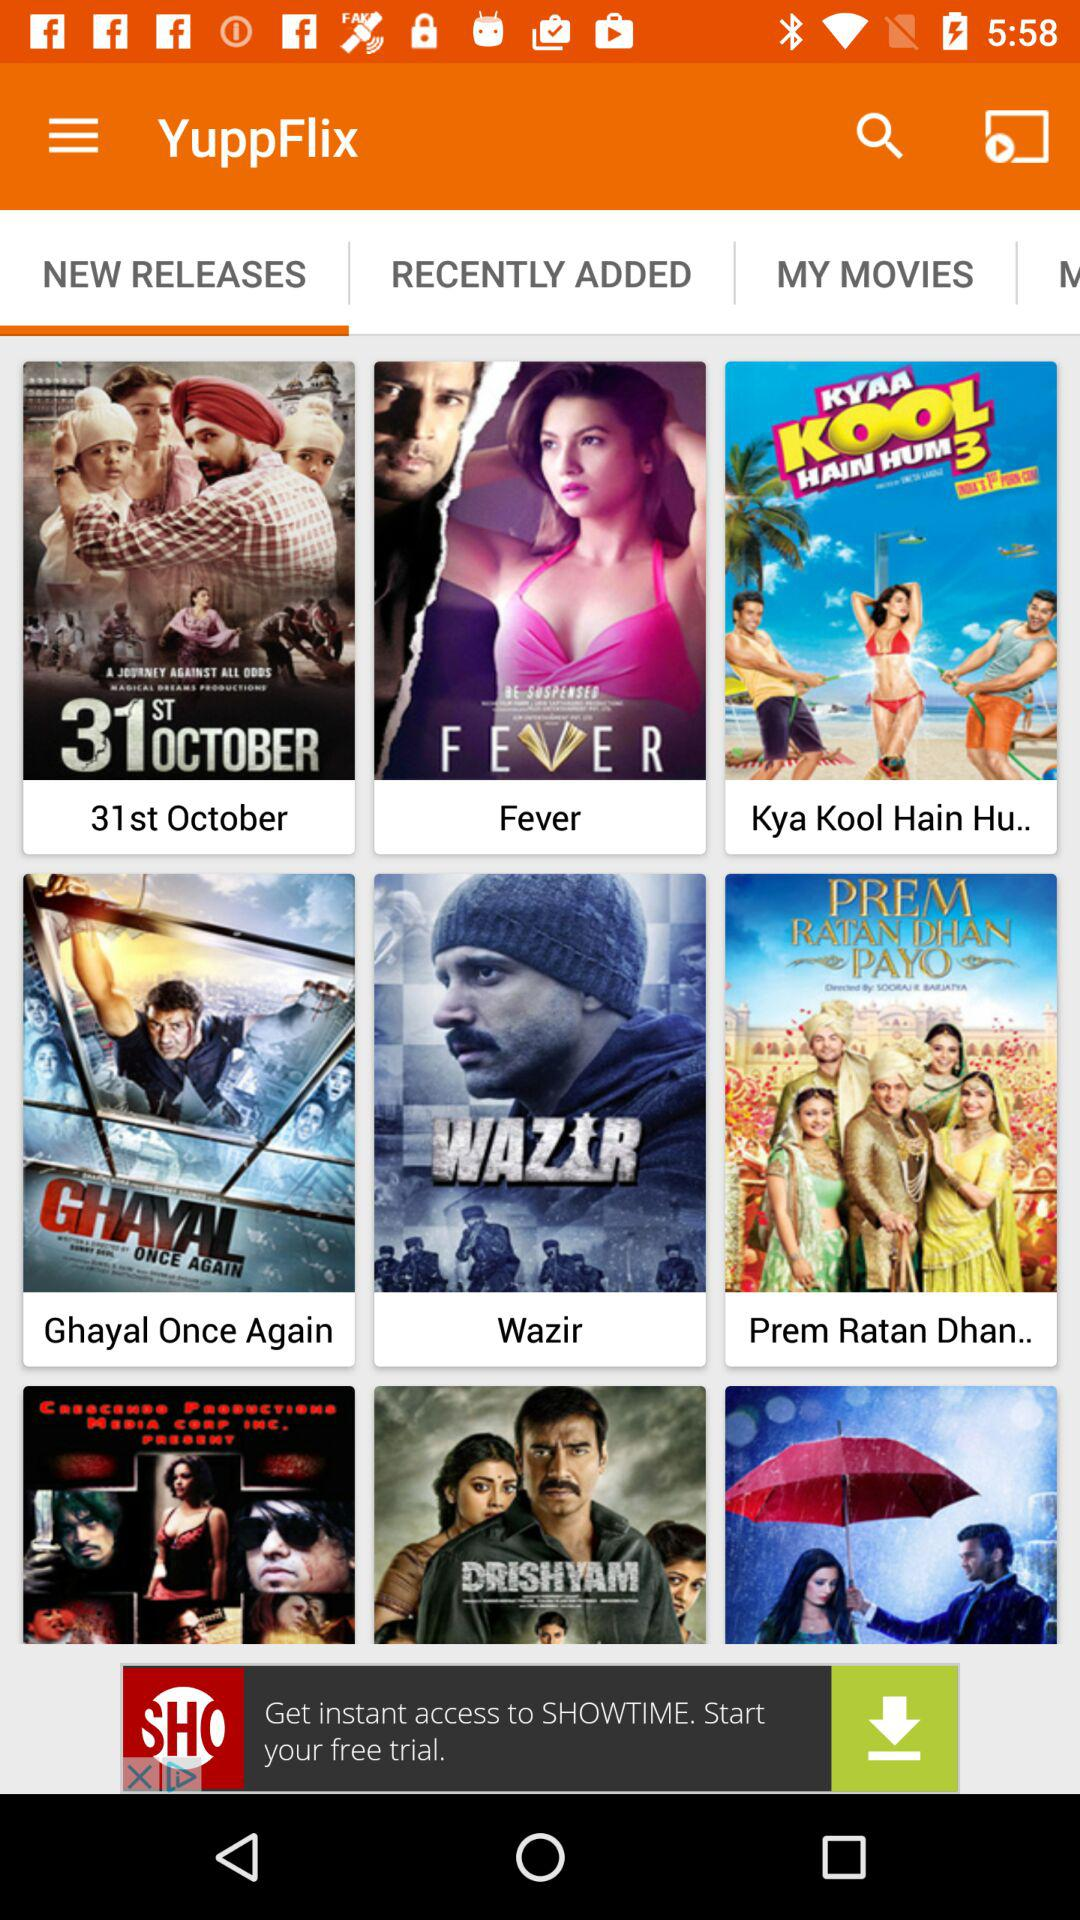Which option is selected? The selected option is "NEW RELEASES". 